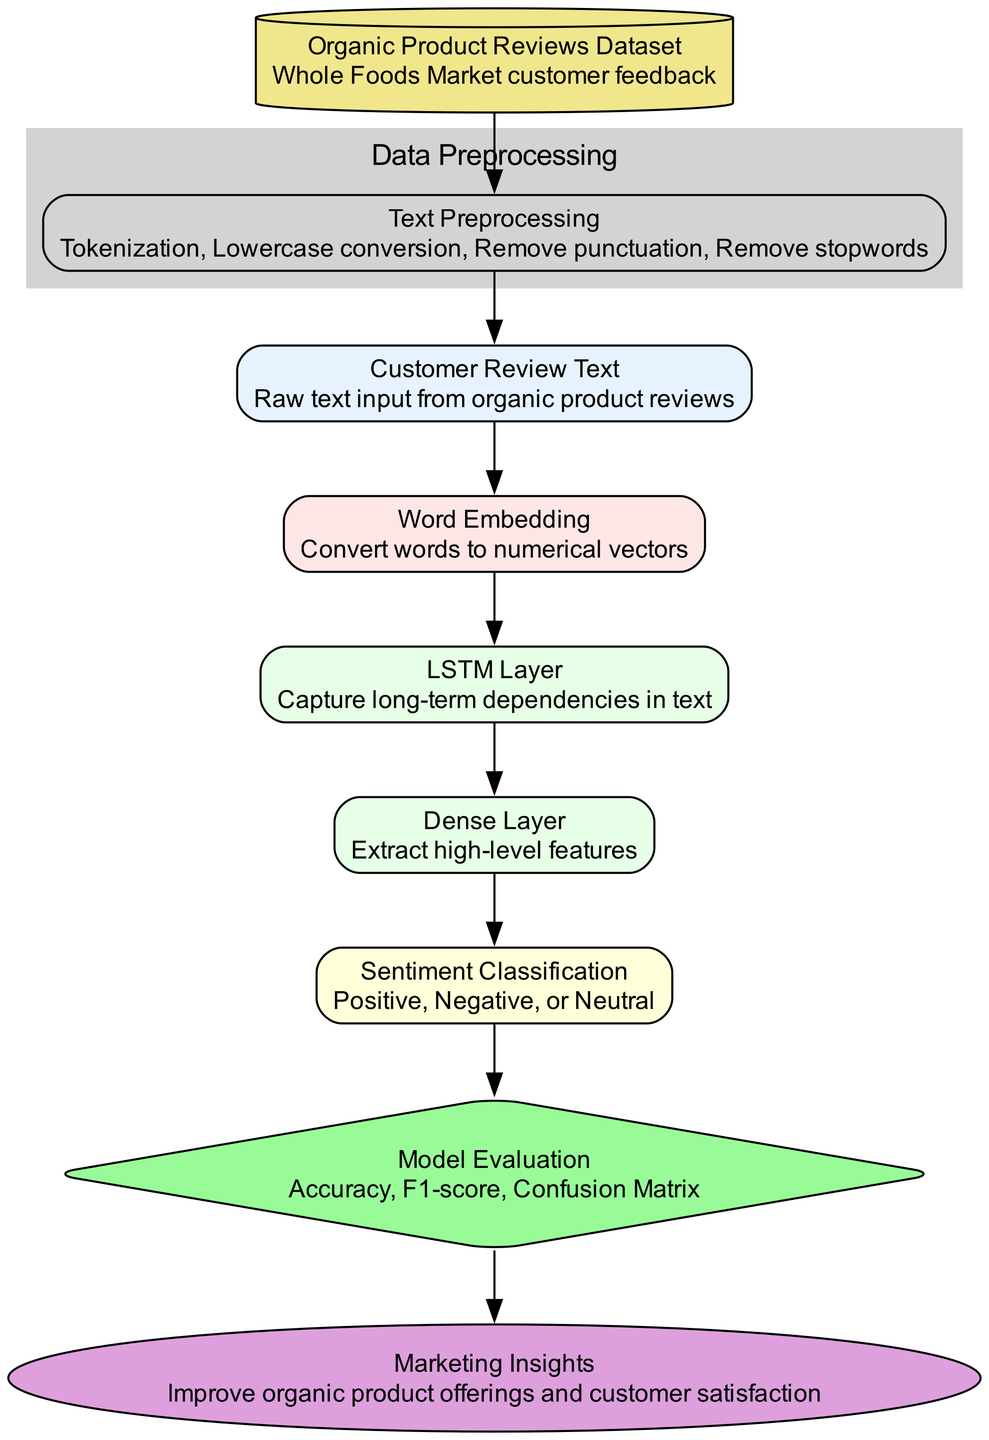What is the name of the input layer? The input layer is labeled as "Customer Review Text," which is directly stated in the diagram.
Answer: Customer Review Text How many hidden layers are there in the architecture? By counting the layers listed under "Hidden Layers," there are two layers identified: an LSTM Layer and a Dense Layer.
Answer: 2 What is the output of the neural network? The output layer specifies "Sentiment Classification," indicating it classifies sentiments.
Answer: Sentiment Classification What are the steps involved in data preprocessing? The steps are listed within the "Data Preprocessing" cluster and include: Tokenization, Lowercase conversion, Remove punctuation, and Remove stopwords.
Answer: Tokenization, Lowercase conversion, Remove punctuation, Remove stopwords Which training data source is used? The training data is noted as "Whole Foods Market customer feedback," which is explicitly mentioned in the diagram.
Answer: Whole Foods Market customer feedback What metrics are utilized for model evaluation? Under the "Model Evaluation" node, three metrics are outlined: Accuracy, F1-score, and Confusion Matrix, providing a clear answer.
Answer: Accuracy, F1-score, Confusion Matrix What is the purpose of the LSTM layer? The description states that the LSTM Layer is intended to "Capture long-term dependencies in text," which indicates its purpose in the architecture.
Answer: Capture long-term dependencies in text How does the output layer connect to the evaluation node? The connection is shown by a directed edge going from the output layer "Sentiment Classification" to the evaluation node "Model Evaluation," indicating this process occurs after sentiment is classified.
Answer: Through a directed edge What is the application use of this neural network architecture? The application is described as "Marketing Insights," suggesting the practical use of the insights derived from sentiment analysis from customer reviews.
Answer: Marketing Insights 